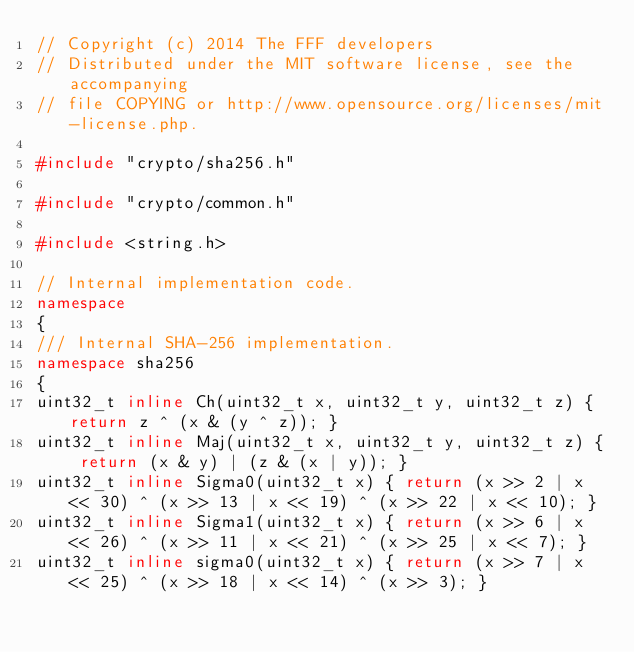Convert code to text. <code><loc_0><loc_0><loc_500><loc_500><_C++_>// Copyright (c) 2014 The FFF developers
// Distributed under the MIT software license, see the accompanying
// file COPYING or http://www.opensource.org/licenses/mit-license.php.

#include "crypto/sha256.h"

#include "crypto/common.h"

#include <string.h>

// Internal implementation code.
namespace
{
/// Internal SHA-256 implementation.
namespace sha256
{
uint32_t inline Ch(uint32_t x, uint32_t y, uint32_t z) { return z ^ (x & (y ^ z)); }
uint32_t inline Maj(uint32_t x, uint32_t y, uint32_t z) { return (x & y) | (z & (x | y)); }
uint32_t inline Sigma0(uint32_t x) { return (x >> 2 | x << 30) ^ (x >> 13 | x << 19) ^ (x >> 22 | x << 10); }
uint32_t inline Sigma1(uint32_t x) { return (x >> 6 | x << 26) ^ (x >> 11 | x << 21) ^ (x >> 25 | x << 7); }
uint32_t inline sigma0(uint32_t x) { return (x >> 7 | x << 25) ^ (x >> 18 | x << 14) ^ (x >> 3); }</code> 